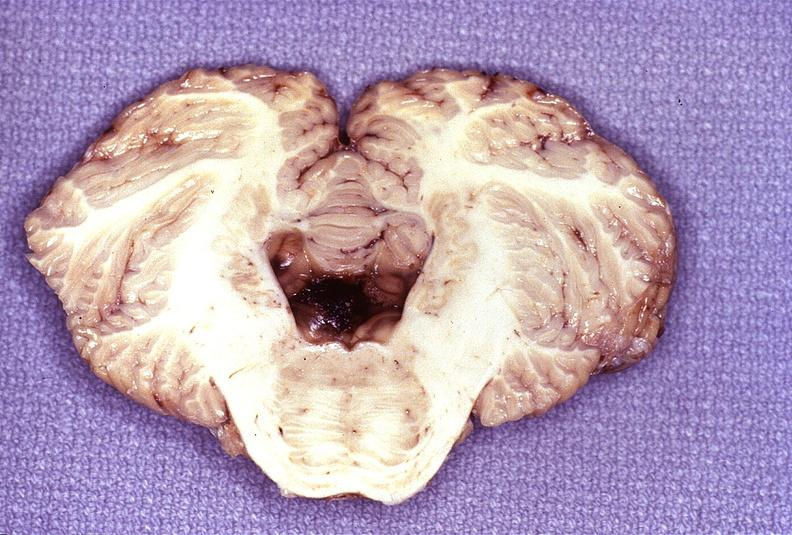does chronic myelogenous leukemia show wernicke 's encephalopathy?
Answer the question using a single word or phrase. No 